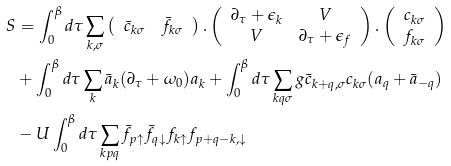<formula> <loc_0><loc_0><loc_500><loc_500>S & = \int _ { 0 } ^ { \beta } d \tau \sum _ { k , \sigma } \left ( \begin{array} { c c } \bar { c } _ { k \sigma } & \bar { f } _ { k \sigma } \\ \end{array} \right ) . \left ( \begin{array} { c c } \partial _ { \tau } + \epsilon _ { k } & V \\ V & \partial _ { \tau } + \epsilon _ { f } \\ \end{array} \right ) . \left ( \begin{array} { c } c _ { k \sigma } \\ f _ { k \sigma } \\ \end{array} \right ) \\ & + \int _ { 0 } ^ { \beta } d \tau \sum _ { k } \bar { a } _ { k } ( \partial _ { \tau } + \omega _ { 0 } ) a _ { k } + \int _ { 0 } ^ { \beta } d \tau \sum _ { k q \sigma } g \bar { c } _ { k + q , \sigma } c _ { k \sigma } ( a _ { q } + \bar { a } _ { - q } ) \\ & - U \int _ { 0 } ^ { \beta } d \tau \sum _ { k p q } \bar { f } _ { p \uparrow } \bar { f } _ { q \downarrow } f _ { k \uparrow } f _ { p + q - k , \downarrow }</formula> 